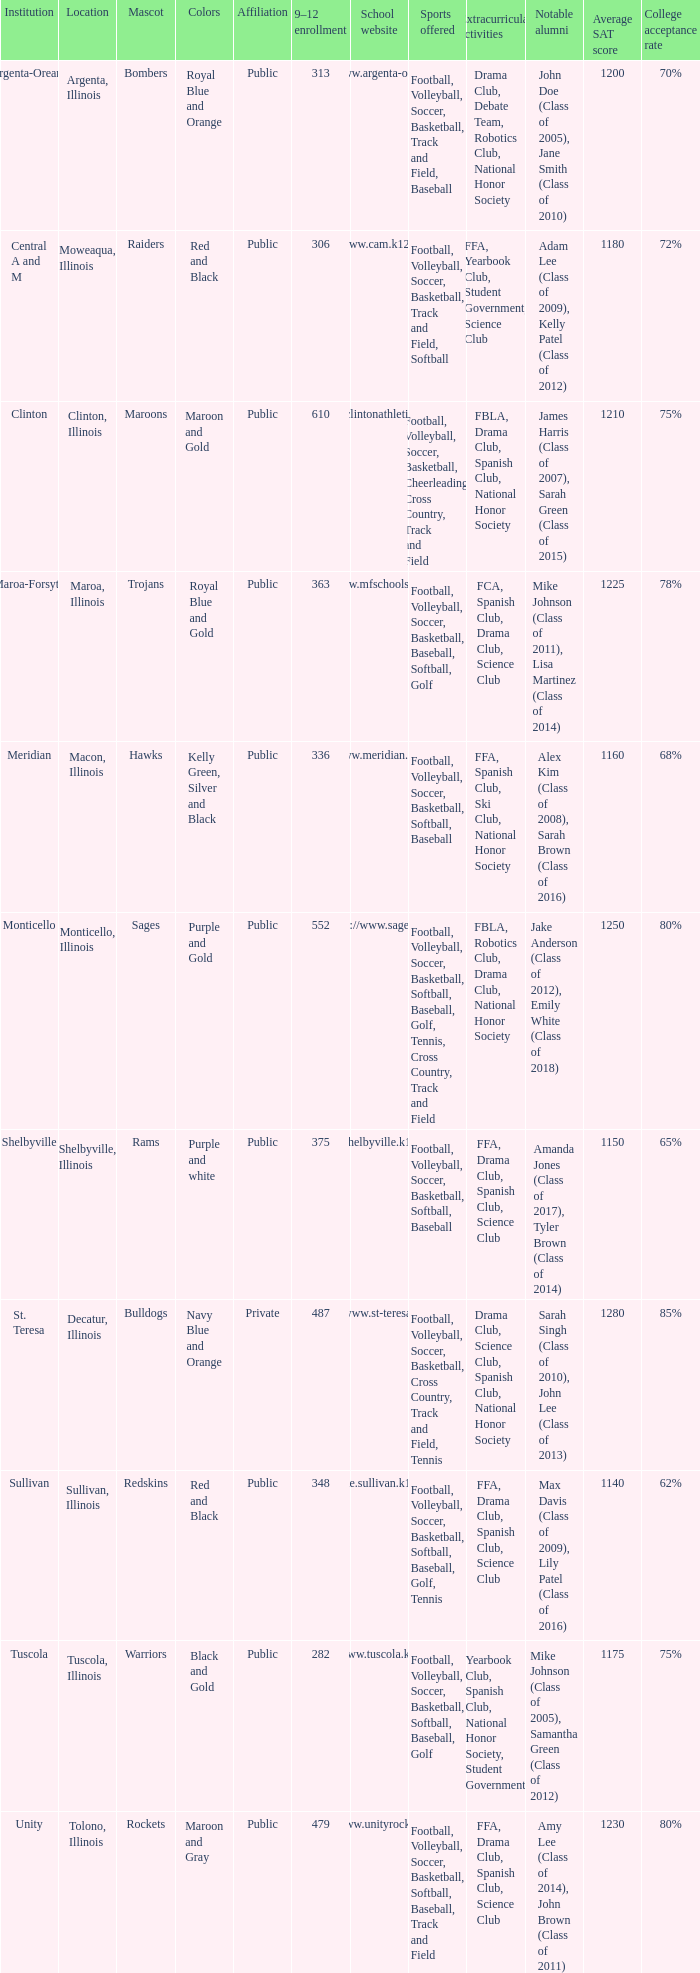How many different combinations of team colors are there in all the schools in Maroa, Illinois? 1.0. 